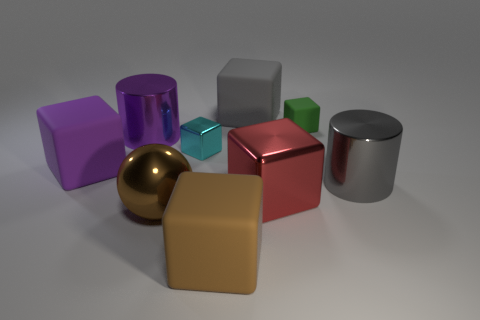Subtract all balls. How many objects are left? 8 Subtract all cyan cubes. How many cubes are left? 5 Subtract all purple cubes. How many cubes are left? 5 Subtract 1 cylinders. How many cylinders are left? 1 Subtract all rubber blocks. Subtract all big brown things. How many objects are left? 3 Add 6 purple rubber blocks. How many purple rubber blocks are left? 7 Add 8 purple metallic cylinders. How many purple metallic cylinders exist? 9 Subtract 0 cyan balls. How many objects are left? 9 Subtract all cyan cylinders. Subtract all purple spheres. How many cylinders are left? 2 Subtract all red balls. How many green cylinders are left? 0 